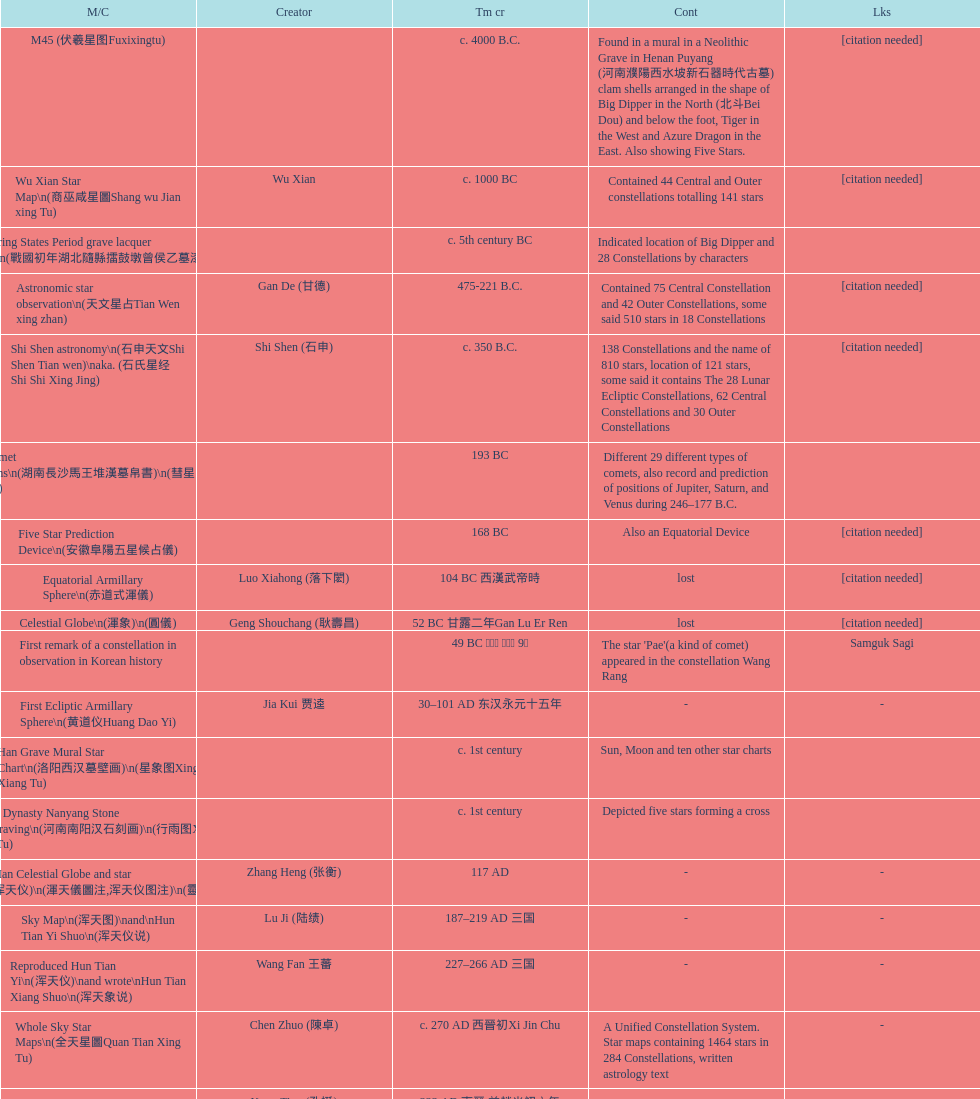Which was the first chinese star map known to have been created? M45 (伏羲星图Fuxixingtu). 